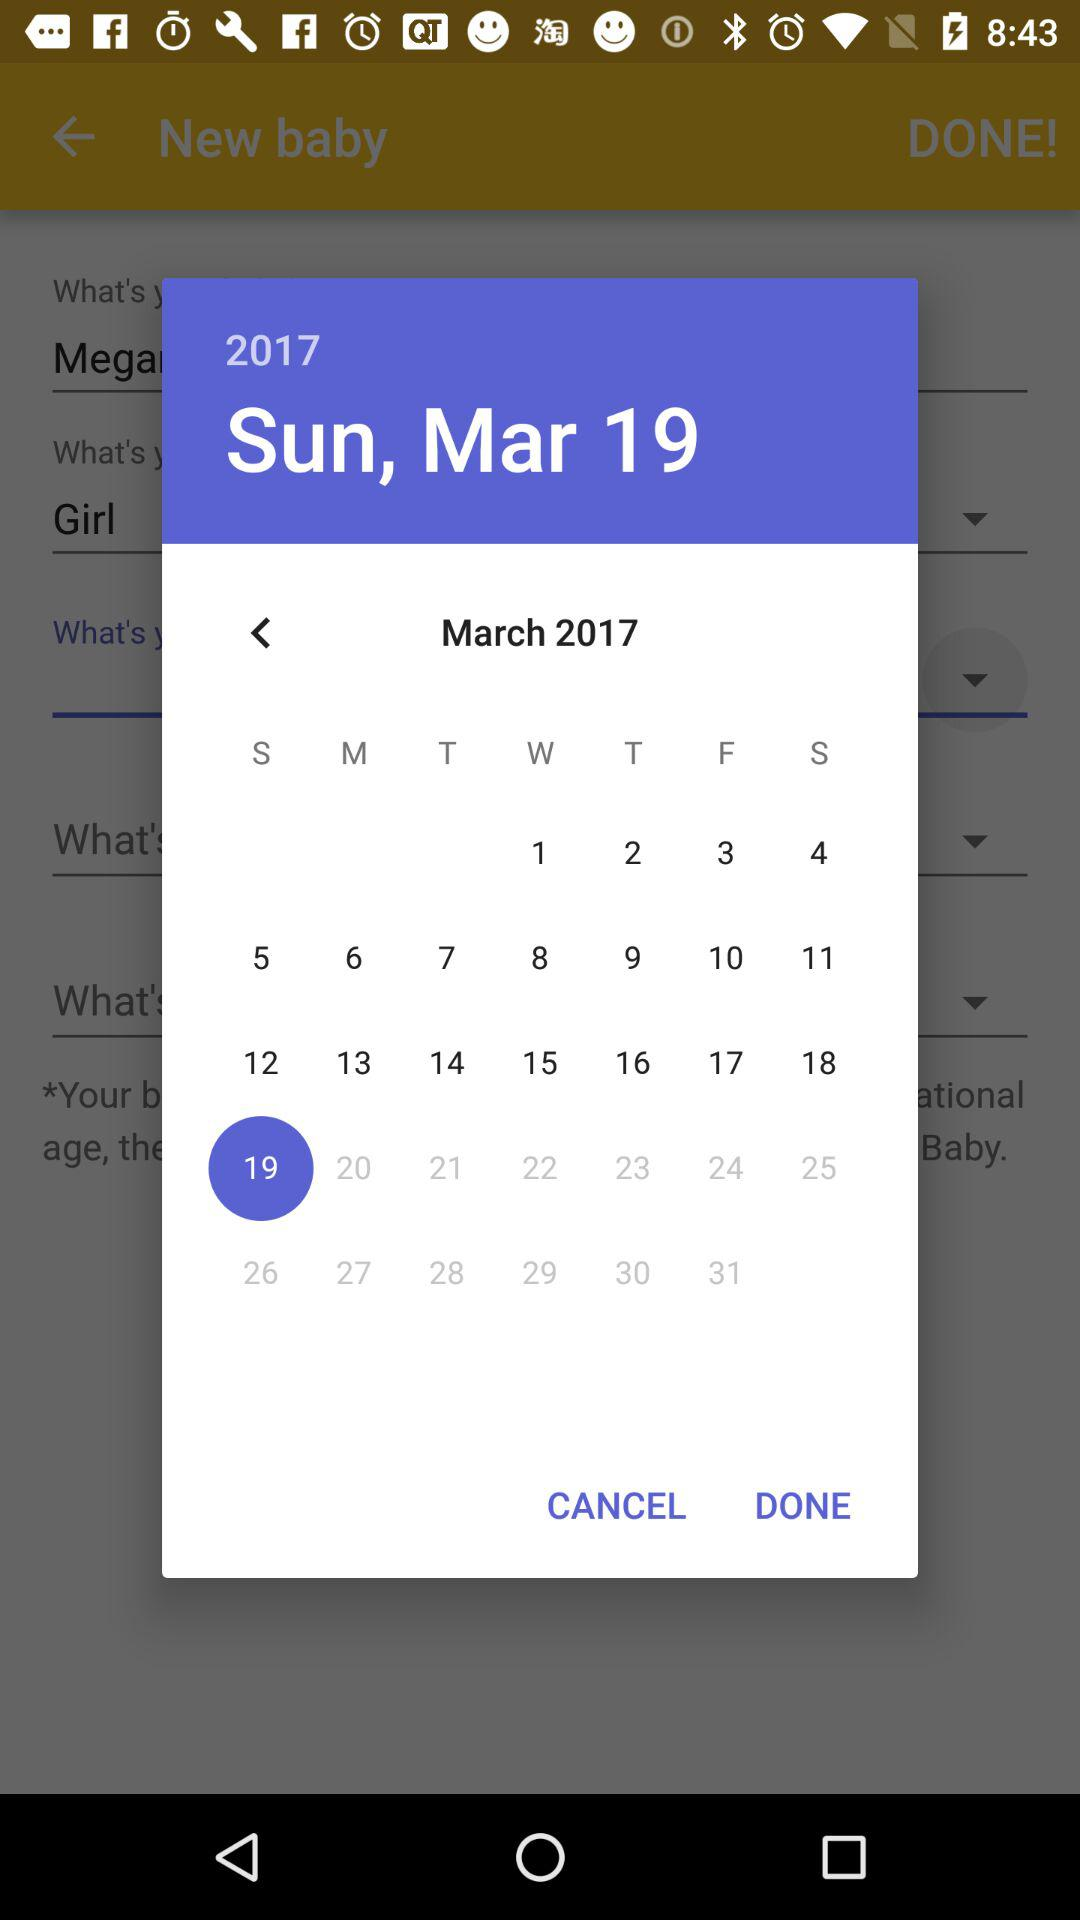What is the day of the selected date? The day is Sunday. 